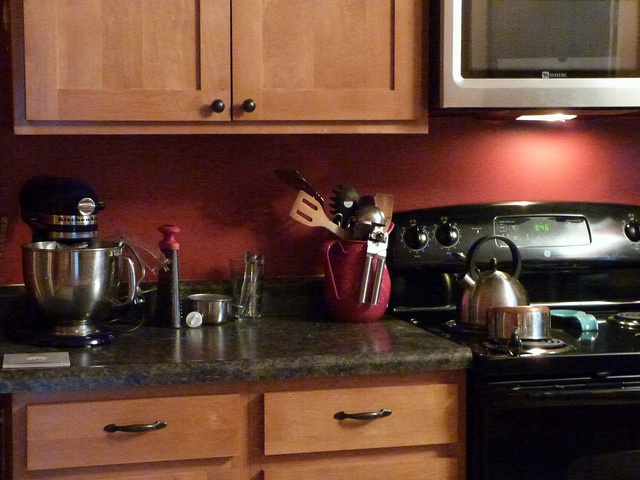Describe the objects in this image and their specific colors. I can see oven in black, gray, white, and darkgray tones, microwave in black, gray, ivory, and darkgray tones, bowl in black, maroon, and gray tones, bottle in black, gray, and maroon tones, and bowl in black and gray tones in this image. 